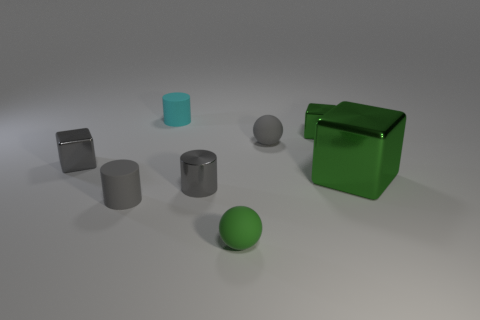Add 1 small cyan cylinders. How many objects exist? 9 Subtract all cylinders. How many objects are left? 5 Add 7 tiny gray shiny things. How many tiny gray shiny things exist? 9 Subtract 0 cyan cubes. How many objects are left? 8 Subtract all gray objects. Subtract all metallic things. How many objects are left? 0 Add 6 gray metallic blocks. How many gray metallic blocks are left? 7 